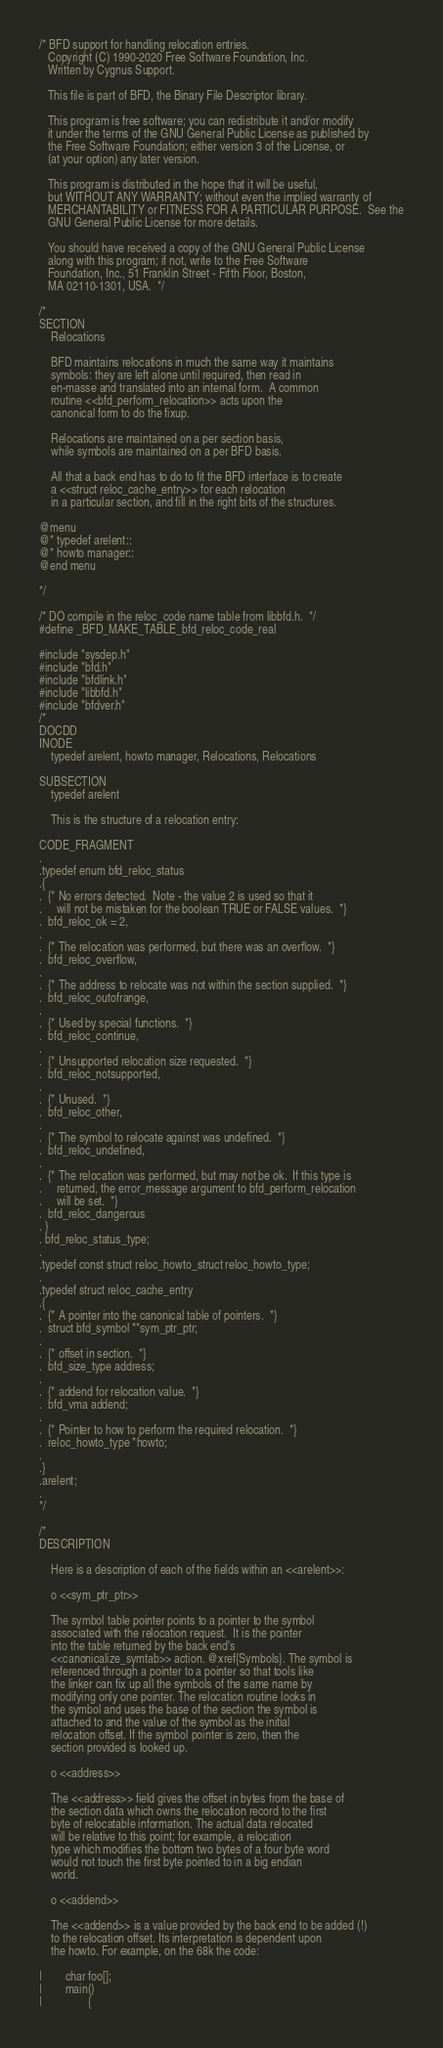Convert code to text. <code><loc_0><loc_0><loc_500><loc_500><_C_>/* BFD support for handling relocation entries.
   Copyright (C) 1990-2020 Free Software Foundation, Inc.
   Written by Cygnus Support.

   This file is part of BFD, the Binary File Descriptor library.

   This program is free software; you can redistribute it and/or modify
   it under the terms of the GNU General Public License as published by
   the Free Software Foundation; either version 3 of the License, or
   (at your option) any later version.

   This program is distributed in the hope that it will be useful,
   but WITHOUT ANY WARRANTY; without even the implied warranty of
   MERCHANTABILITY or FITNESS FOR A PARTICULAR PURPOSE.  See the
   GNU General Public License for more details.

   You should have received a copy of the GNU General Public License
   along with this program; if not, write to the Free Software
   Foundation, Inc., 51 Franklin Street - Fifth Floor, Boston,
   MA 02110-1301, USA.  */

/*
SECTION
	Relocations

	BFD maintains relocations in much the same way it maintains
	symbols: they are left alone until required, then read in
	en-masse and translated into an internal form.  A common
	routine <<bfd_perform_relocation>> acts upon the
	canonical form to do the fixup.

	Relocations are maintained on a per section basis,
	while symbols are maintained on a per BFD basis.

	All that a back end has to do to fit the BFD interface is to create
	a <<struct reloc_cache_entry>> for each relocation
	in a particular section, and fill in the right bits of the structures.

@menu
@* typedef arelent::
@* howto manager::
@end menu

*/

/* DO compile in the reloc_code name table from libbfd.h.  */
#define _BFD_MAKE_TABLE_bfd_reloc_code_real

#include "sysdep.h"
#include "bfd.h"
#include "bfdlink.h"
#include "libbfd.h"
#include "bfdver.h"
/*
DOCDD
INODE
	typedef arelent, howto manager, Relocations, Relocations

SUBSECTION
	typedef arelent

	This is the structure of a relocation entry:

CODE_FRAGMENT
.
.typedef enum bfd_reloc_status
.{
.  {* No errors detected.  Note - the value 2 is used so that it
.     will not be mistaken for the boolean TRUE or FALSE values.  *}
.  bfd_reloc_ok = 2,
.
.  {* The relocation was performed, but there was an overflow.  *}
.  bfd_reloc_overflow,
.
.  {* The address to relocate was not within the section supplied.  *}
.  bfd_reloc_outofrange,
.
.  {* Used by special functions.  *}
.  bfd_reloc_continue,
.
.  {* Unsupported relocation size requested.  *}
.  bfd_reloc_notsupported,
.
.  {* Unused.  *}
.  bfd_reloc_other,
.
.  {* The symbol to relocate against was undefined.  *}
.  bfd_reloc_undefined,
.
.  {* The relocation was performed, but may not be ok.  If this type is
.     returned, the error_message argument to bfd_perform_relocation
.     will be set.  *}
.  bfd_reloc_dangerous
. }
. bfd_reloc_status_type;
.
.typedef const struct reloc_howto_struct reloc_howto_type;
.
.typedef struct reloc_cache_entry
.{
.  {* A pointer into the canonical table of pointers.  *}
.  struct bfd_symbol **sym_ptr_ptr;
.
.  {* offset in section.  *}
.  bfd_size_type address;
.
.  {* addend for relocation value.  *}
.  bfd_vma addend;
.
.  {* Pointer to how to perform the required relocation.  *}
.  reloc_howto_type *howto;
.
.}
.arelent;
.
*/

/*
DESCRIPTION

	Here is a description of each of the fields within an <<arelent>>:

	o <<sym_ptr_ptr>>

	The symbol table pointer points to a pointer to the symbol
	associated with the relocation request.  It is the pointer
	into the table returned by the back end's
	<<canonicalize_symtab>> action. @xref{Symbols}. The symbol is
	referenced through a pointer to a pointer so that tools like
	the linker can fix up all the symbols of the same name by
	modifying only one pointer. The relocation routine looks in
	the symbol and uses the base of the section the symbol is
	attached to and the value of the symbol as the initial
	relocation offset. If the symbol pointer is zero, then the
	section provided is looked up.

	o <<address>>

	The <<address>> field gives the offset in bytes from the base of
	the section data which owns the relocation record to the first
	byte of relocatable information. The actual data relocated
	will be relative to this point; for example, a relocation
	type which modifies the bottom two bytes of a four byte word
	would not touch the first byte pointed to in a big endian
	world.

	o <<addend>>

	The <<addend>> is a value provided by the back end to be added (!)
	to the relocation offset. Its interpretation is dependent upon
	the howto. For example, on the 68k the code:

|        char foo[];
|        main()
|                {</code> 